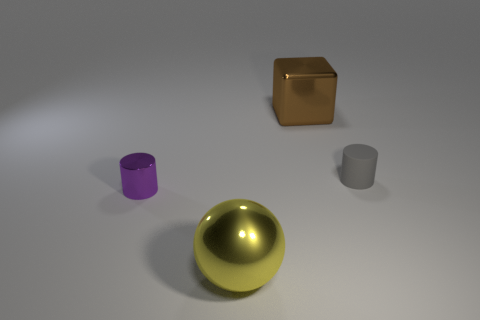What is the size of the shiny object to the right of the yellow ball?
Provide a short and direct response. Large. There is a object that is behind the small gray matte cylinder; does it have the same color as the shiny thing that is in front of the small purple metal thing?
Your answer should be compact. No. How many other things are the same shape as the large yellow metal object?
Make the answer very short. 0. Is the number of small gray rubber cylinders that are behind the gray cylinder the same as the number of big objects behind the big block?
Give a very brief answer. Yes. Are the large object that is behind the tiny purple metal object and the small thing that is on the left side of the big brown thing made of the same material?
Your answer should be compact. Yes. How many other objects are the same size as the rubber object?
Give a very brief answer. 1. How many objects are small shiny cylinders or small objects on the left side of the gray matte cylinder?
Ensure brevity in your answer.  1. Is the number of brown things that are left of the purple cylinder the same as the number of large gray metal blocks?
Provide a succinct answer. Yes. There is a brown thing that is the same material as the tiny purple thing; what is its shape?
Offer a terse response. Cube. Are there any big rubber things that have the same color as the rubber cylinder?
Your response must be concise. No. 